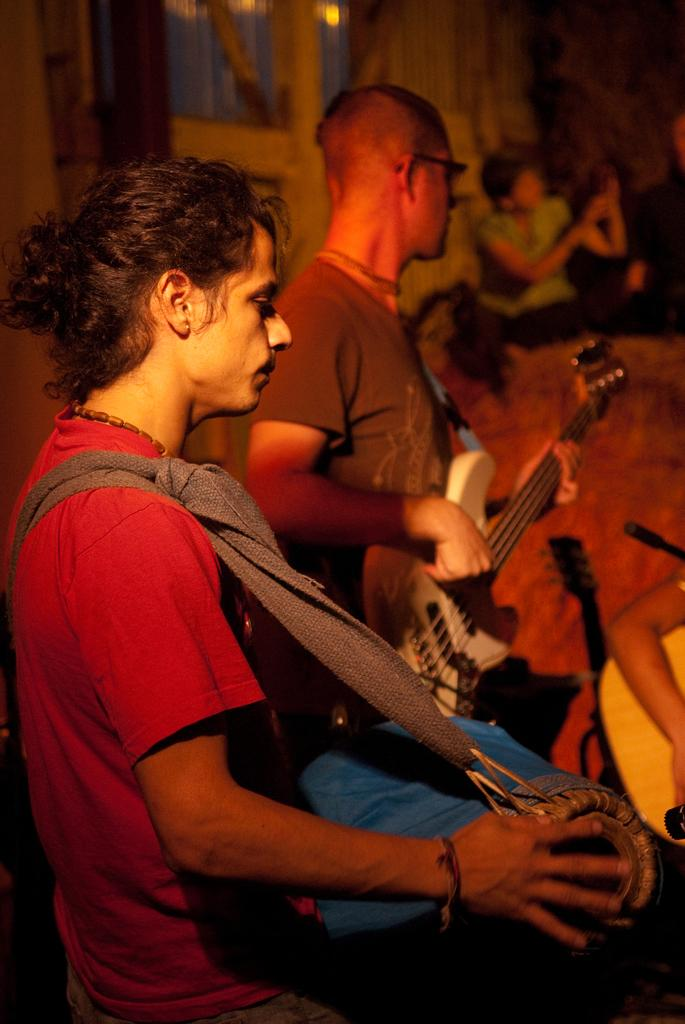Where is the setting of the image? The image is inside a home. Who is present in the image? There are persons in the image. What are the persons doing in the image? The persons are holding musical instruments. Can you identify any specific musical instruments in the image? Yes, one of the musical instruments is a drum, and another is a violin. What type of trousers are the persons wearing in the image? There is no information about the clothing of the persons in the image, so we cannot determine what type of trousers they might be wearing. 